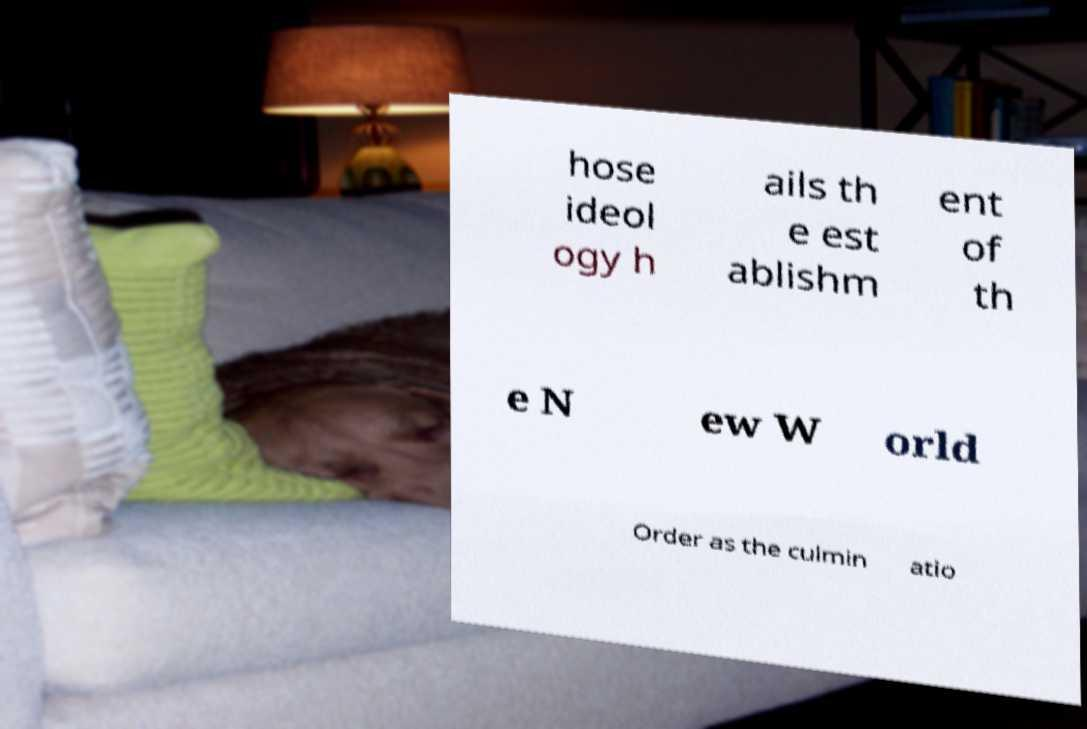Please read and relay the text visible in this image. What does it say? hose ideol ogy h ails th e est ablishm ent of th e N ew W orld Order as the culmin atio 